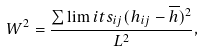<formula> <loc_0><loc_0><loc_500><loc_500>W ^ { 2 } = \frac { \sum \lim i t s _ { i j } ( h _ { i j } - \overline { h } ) ^ { 2 } } { L ^ { 2 } } ,</formula> 